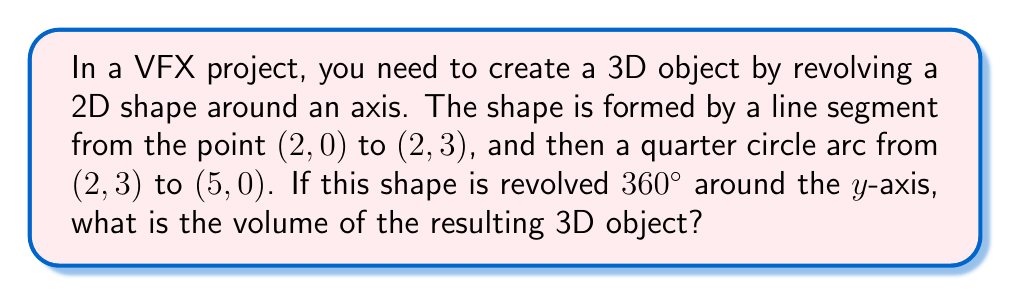Solve this math problem. To solve this problem, we'll use the method of shells for volumes of revolution. We'll break down the shape into two parts: a cylinder and a dome-like shape.

1. Volume of the cylinder:
   The cylinder is formed by revolving the line segment from (2, 0) to (2, 3) around the y-axis.
   Volume of a cylinder: $V = \pi r^2 h$
   $r = 2$, $h = 3$
   $V_1 = \pi (2)^2 (3) = 12\pi$

2. Volume of the dome-like shape:
   This is formed by revolving the quarter circle arc from (2, 3) to (5, 0) around the y-axis.
   We'll use the shell method: $V = 2\pi \int_a^b x f(x) dx$
   
   The equation of the circle centered at (5, 0) with radius 3 is:
   $(x-5)^2 + y^2 = 3^2$
   
   Solving for y: $y = \sqrt{9 - (x-5)^2}$
   
   Now we can set up the integral:
   $V_2 = 2\pi \int_2^5 x \sqrt{9 - (x-5)^2} dx$
   
   This integral is complex, but it can be solved using substitution and trigonometric identities. The result is:
   $V_2 = 2\pi (\frac{27}{4} - \frac{9\sqrt{3}}{2}) = \frac{27\pi}{2} - 9\sqrt{3}\pi$

3. Total volume:
   $V_{total} = V_1 + V_2 = 12\pi + \frac{27\pi}{2} - 9\sqrt{3}\pi = \frac{51\pi}{2} - 9\sqrt{3}\pi$
Answer: $\frac{51\pi}{2} - 9\sqrt{3}\pi$ cubic units 